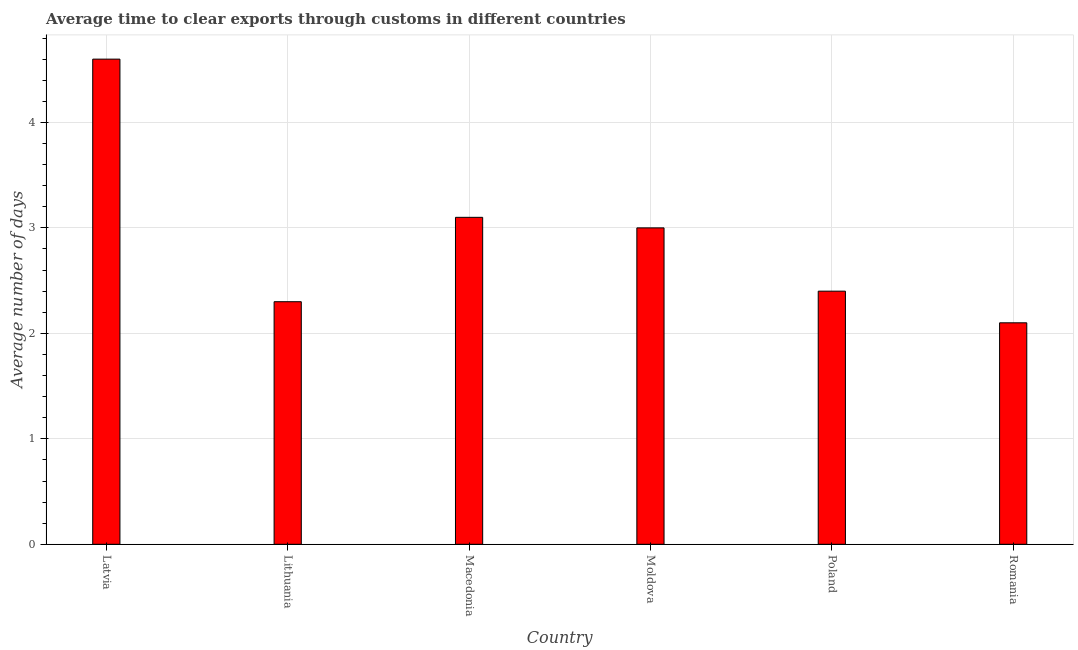Does the graph contain any zero values?
Offer a very short reply. No. Does the graph contain grids?
Ensure brevity in your answer.  Yes. What is the title of the graph?
Give a very brief answer. Average time to clear exports through customs in different countries. What is the label or title of the X-axis?
Ensure brevity in your answer.  Country. What is the label or title of the Y-axis?
Your answer should be very brief. Average number of days. What is the time to clear exports through customs in Poland?
Keep it short and to the point. 2.4. Across all countries, what is the minimum time to clear exports through customs?
Your answer should be compact. 2.1. In which country was the time to clear exports through customs maximum?
Ensure brevity in your answer.  Latvia. In which country was the time to clear exports through customs minimum?
Your response must be concise. Romania. What is the difference between the time to clear exports through customs in Lithuania and Moldova?
Keep it short and to the point. -0.7. What is the average time to clear exports through customs per country?
Give a very brief answer. 2.92. What is the ratio of the time to clear exports through customs in Lithuania to that in Moldova?
Provide a succinct answer. 0.77. Is the time to clear exports through customs in Moldova less than that in Romania?
Ensure brevity in your answer.  No. Is the difference between the time to clear exports through customs in Lithuania and Macedonia greater than the difference between any two countries?
Offer a terse response. No. What is the difference between the highest and the second highest time to clear exports through customs?
Your answer should be compact. 1.5. How many countries are there in the graph?
Ensure brevity in your answer.  6. What is the difference between two consecutive major ticks on the Y-axis?
Give a very brief answer. 1. What is the Average number of days in Moldova?
Ensure brevity in your answer.  3. What is the Average number of days of Poland?
Provide a succinct answer. 2.4. What is the difference between the Average number of days in Latvia and Macedonia?
Your answer should be very brief. 1.5. What is the difference between the Average number of days in Latvia and Poland?
Give a very brief answer. 2.2. What is the difference between the Average number of days in Lithuania and Macedonia?
Keep it short and to the point. -0.8. What is the difference between the Average number of days in Lithuania and Romania?
Provide a succinct answer. 0.2. What is the difference between the Average number of days in Macedonia and Poland?
Keep it short and to the point. 0.7. What is the difference between the Average number of days in Moldova and Romania?
Make the answer very short. 0.9. What is the ratio of the Average number of days in Latvia to that in Macedonia?
Your answer should be very brief. 1.48. What is the ratio of the Average number of days in Latvia to that in Moldova?
Your response must be concise. 1.53. What is the ratio of the Average number of days in Latvia to that in Poland?
Offer a terse response. 1.92. What is the ratio of the Average number of days in Latvia to that in Romania?
Offer a very short reply. 2.19. What is the ratio of the Average number of days in Lithuania to that in Macedonia?
Keep it short and to the point. 0.74. What is the ratio of the Average number of days in Lithuania to that in Moldova?
Your answer should be very brief. 0.77. What is the ratio of the Average number of days in Lithuania to that in Poland?
Ensure brevity in your answer.  0.96. What is the ratio of the Average number of days in Lithuania to that in Romania?
Make the answer very short. 1.09. What is the ratio of the Average number of days in Macedonia to that in Moldova?
Offer a very short reply. 1.03. What is the ratio of the Average number of days in Macedonia to that in Poland?
Offer a terse response. 1.29. What is the ratio of the Average number of days in Macedonia to that in Romania?
Your answer should be very brief. 1.48. What is the ratio of the Average number of days in Moldova to that in Poland?
Offer a very short reply. 1.25. What is the ratio of the Average number of days in Moldova to that in Romania?
Keep it short and to the point. 1.43. What is the ratio of the Average number of days in Poland to that in Romania?
Ensure brevity in your answer.  1.14. 